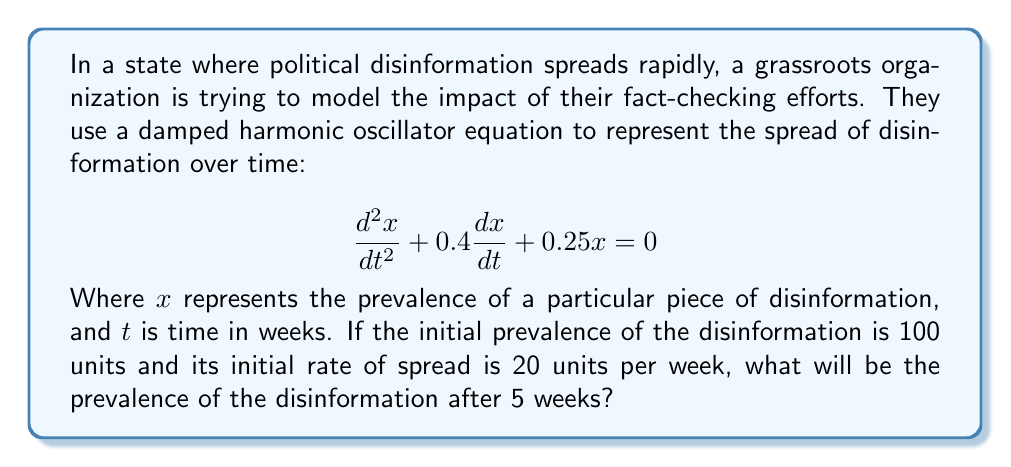Solve this math problem. To solve this problem, we need to follow these steps:

1) The general solution for a damped harmonic oscillator equation is:
   $$x(t) = e^{-bt/2}(A\cos(\omega t) + B\sin(\omega t))$$
   where $b$ is the damping coefficient and $\omega$ is the angular frequency.

2) From our equation, we can identify:
   $b = 0.4$ and $\omega^2 = 0.25 - (0.4/2)^2 = 0.21$
   So, $\omega = \sqrt{0.21} \approx 0.458$

3) Our solution becomes:
   $$x(t) = e^{-0.2t}(A\cos(0.458t) + B\sin(0.458t))$$

4) We need to find $A$ and $B$ using initial conditions:
   At $t=0$, $x(0) = 100$ and $x'(0) = 20$

5) From $x(0) = 100$, we get:
   $$100 = A$$

6) From $x'(0) = 20$, we get:
   $$20 = -0.2A + 0.458B$$
   $$20 = -20 + 0.458B$$
   $$B \approx 87.336$$

7) Our final solution is:
   $$x(t) = e^{-0.2t}(100\cos(0.458t) + 87.336\sin(0.458t))$$

8) To find the prevalence after 5 weeks, we substitute $t=5$:
   $$x(5) = e^{-1}(100\cos(2.29) + 87.336\sin(2.29))$$

9) Calculating this gives us:
   $$x(5) \approx 36.788 \times (-0.668 + 0.744) \approx 2.79$$
Answer: The prevalence of the disinformation after 5 weeks will be approximately 2.79 units. 